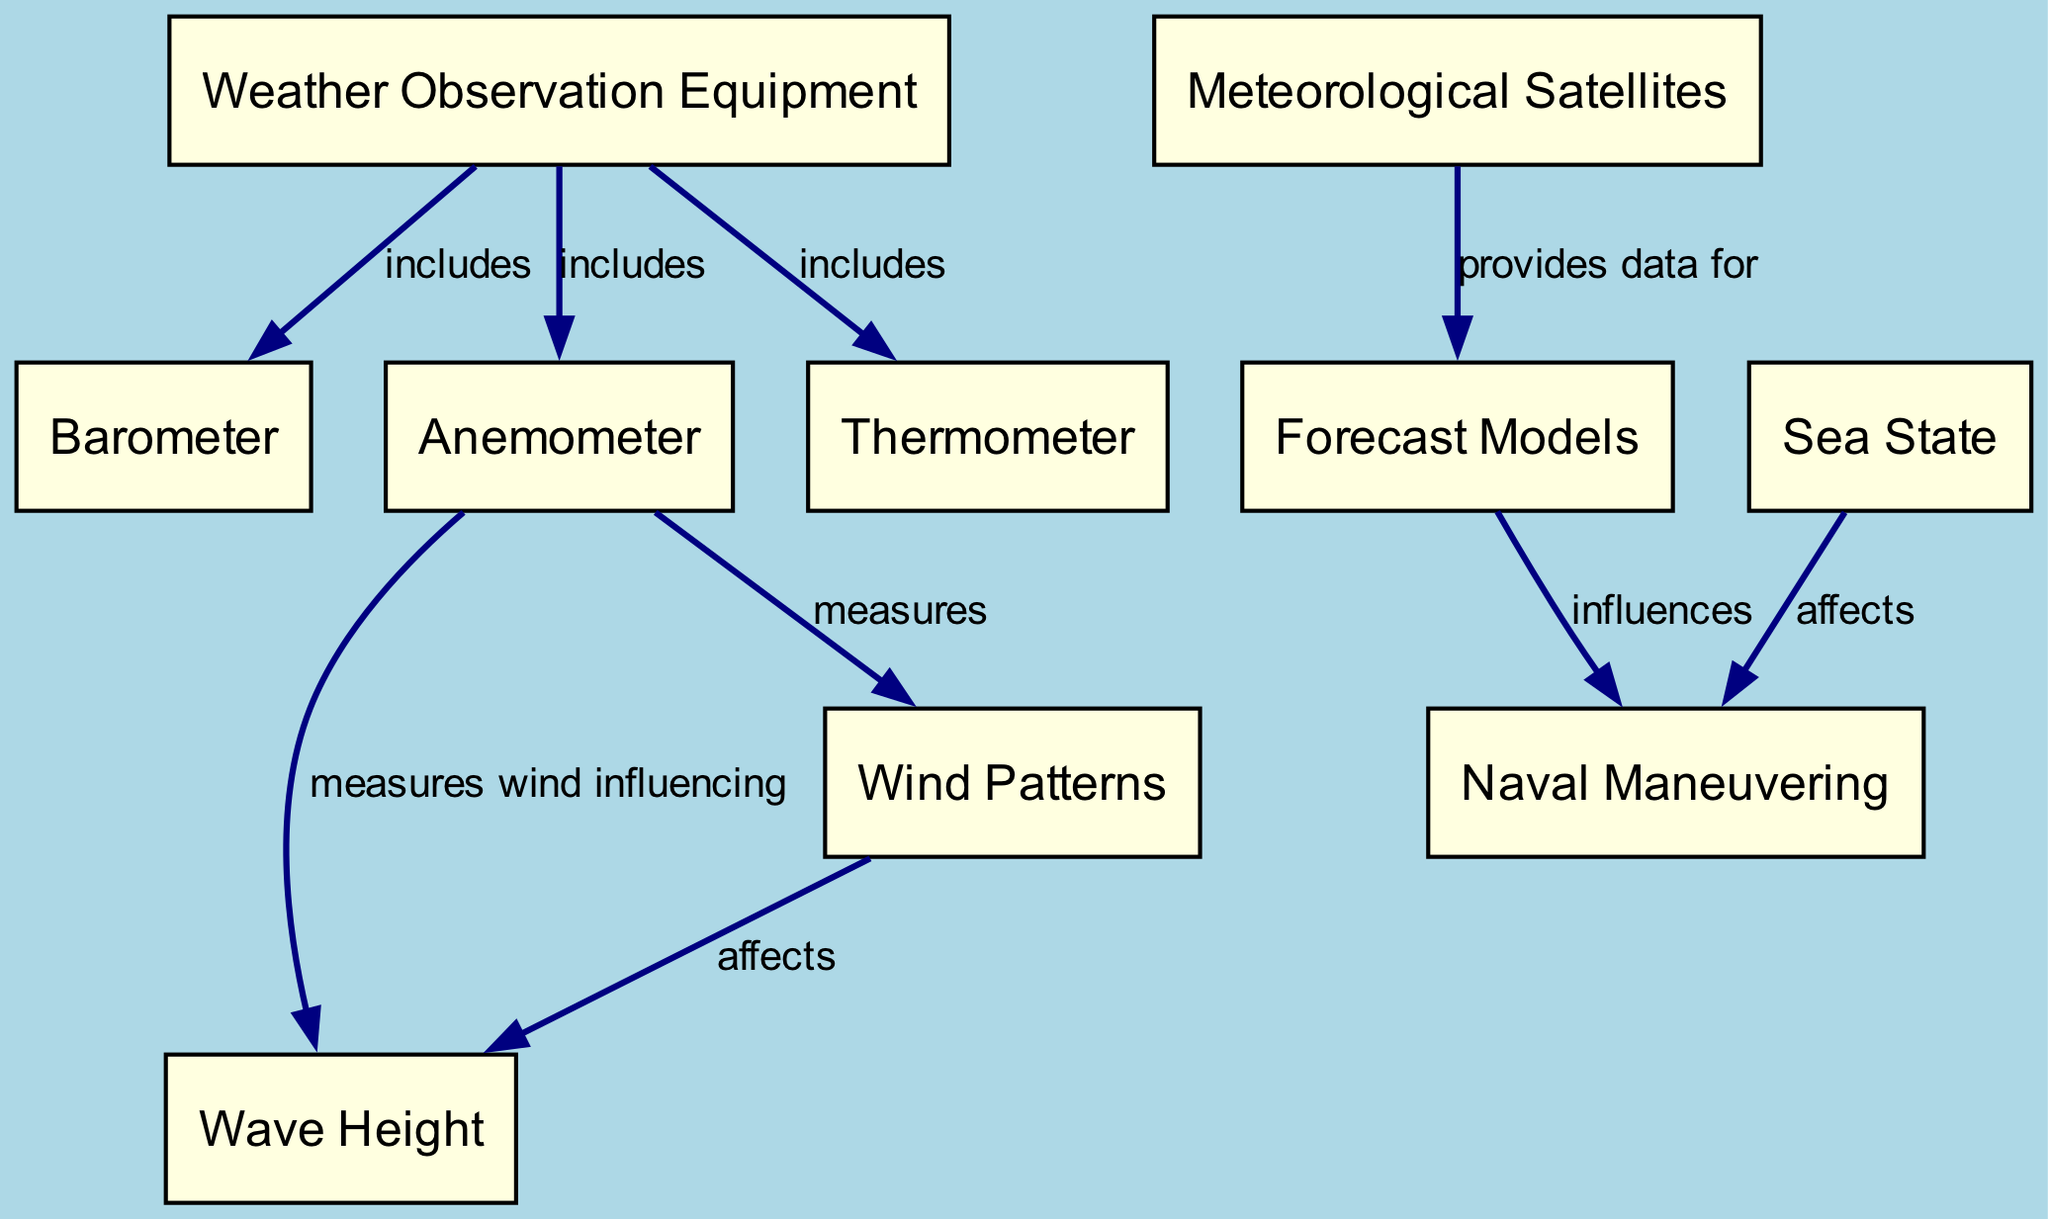What is the total number of nodes in the diagram? The diagram lists 10 distinct nodes: Weather Observation Equipment, Meteorological Satellites, Barometer, Anemometer, Thermometer, Forecast Models, Naval Maneuvering, Sea State, Wave Height, and Wind Patterns. Thus, the total number of nodes is 10.
Answer: 10 Which device measures wind speed? The diagram indicates that the Anemometer (node 4) is the instrument specifically used to measure wind speed and direction.
Answer: Anemometer What does the Meteorological Satellites node provide data for? The diagram shows that Meteorological Satellites (node 2) provide data for Forecast Models (node 6), indicating their role in gathering essential weather information.
Answer: Forecast Models How many edges connect the Weather Observation Equipment node? The edges connected to the Weather Observation Equipment node (node 1) include three: to Barometer (node 3), Anemometer (node 4), and Thermometer (node 5). Thus, the total number of edges connecting this node is 3.
Answer: 3 What influences Naval Maneuvering according to the diagram? The diagram specifies that both Forecast Models (node 6) and Sea State (node 8) influence Naval Maneuvering (node 7). This demonstrates the impact of weather forecasts and sea conditions on naval operations.
Answer: Forecast Models and Sea State Which node is responsible for measuring wave height? The diagram indicates that the node Wave Height (node 9) is connected from the Anemometer (node 4), which measures wind that influences wave height. Thus, Wave Height is the specific node responsible for this measurement.
Answer: Wave Height What does the Anemometer measure according to the diagram? The diagram states that the Anemometer (node 4) measures wind speed and is also connected to Wave Height as it influences it through wind. Therefore, its primary function in the diagram is to measure wind speed.
Answer: Wind Speed How are wind patterns related to wave height? In the diagram, wind patterns (node 10) are illustrated as affecting wave height (node 9). This denotes a direct correlation where changes in wind patterns can modify wave height.
Answer: Affect 